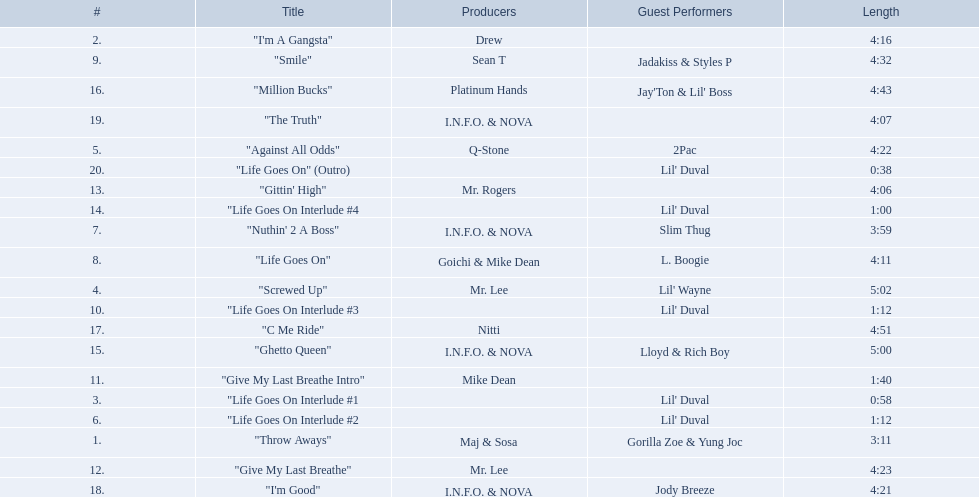What are the song lengths of all the songs on the album? 3:11, 4:16, 0:58, 5:02, 4:22, 1:12, 3:59, 4:11, 4:32, 1:12, 1:40, 4:23, 4:06, 1:00, 5:00, 4:43, 4:51, 4:21, 4:07, 0:38. Which is the longest of these? 5:02. 